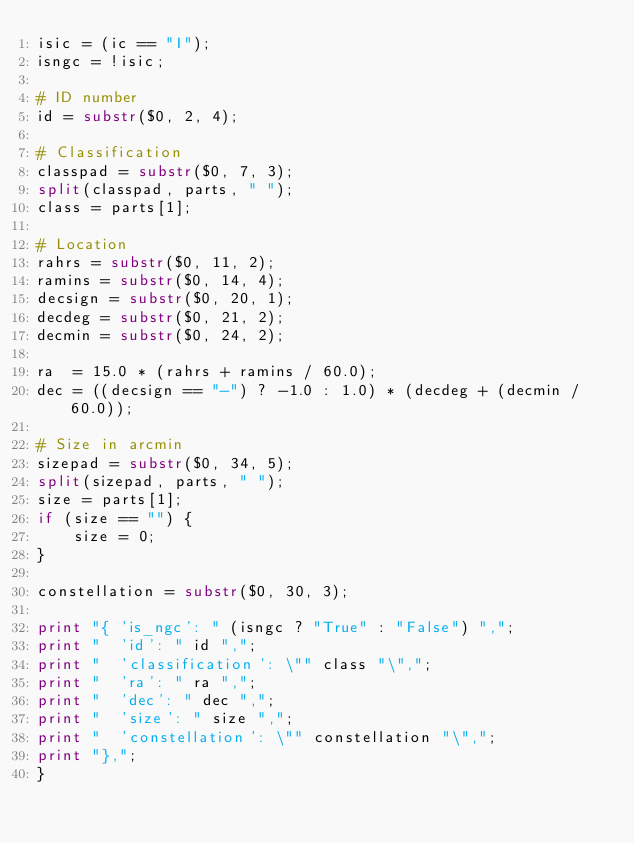Convert code to text. <code><loc_0><loc_0><loc_500><loc_500><_Awk_>isic = (ic == "I");
isngc = !isic;

# ID number
id = substr($0, 2, 4);

# Classification
classpad = substr($0, 7, 3);
split(classpad, parts, " ");
class = parts[1];

# Location
rahrs = substr($0, 11, 2);
ramins = substr($0, 14, 4);
decsign = substr($0, 20, 1);
decdeg = substr($0, 21, 2);
decmin = substr($0, 24, 2);

ra  = 15.0 * (rahrs + ramins / 60.0);
dec = ((decsign == "-") ? -1.0 : 1.0) * (decdeg + (decmin / 60.0));

# Size in arcmin
sizepad = substr($0, 34, 5);
split(sizepad, parts, " ");
size = parts[1];
if (size == "") {
	size = 0;
}

constellation = substr($0, 30, 3);

print "{ 'is_ngc': " (isngc ? "True" : "False") ",";
print "  'id': " id ",";
print "  'classification': \"" class "\",";
print "  'ra': " ra ",";
print "  'dec': " dec ",";
print "  'size': " size ",";
print "  'constellation': \"" constellation "\",";
print "},";
}
</code> 